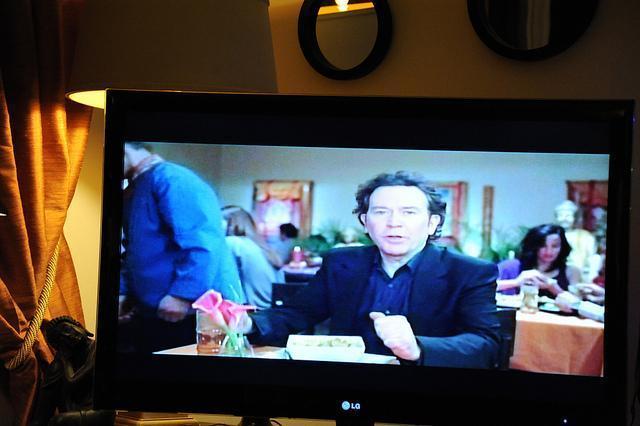How many dining tables can be seen?
Give a very brief answer. 2. How many people are there?
Give a very brief answer. 3. How many chairs are behind the pole?
Give a very brief answer. 0. 